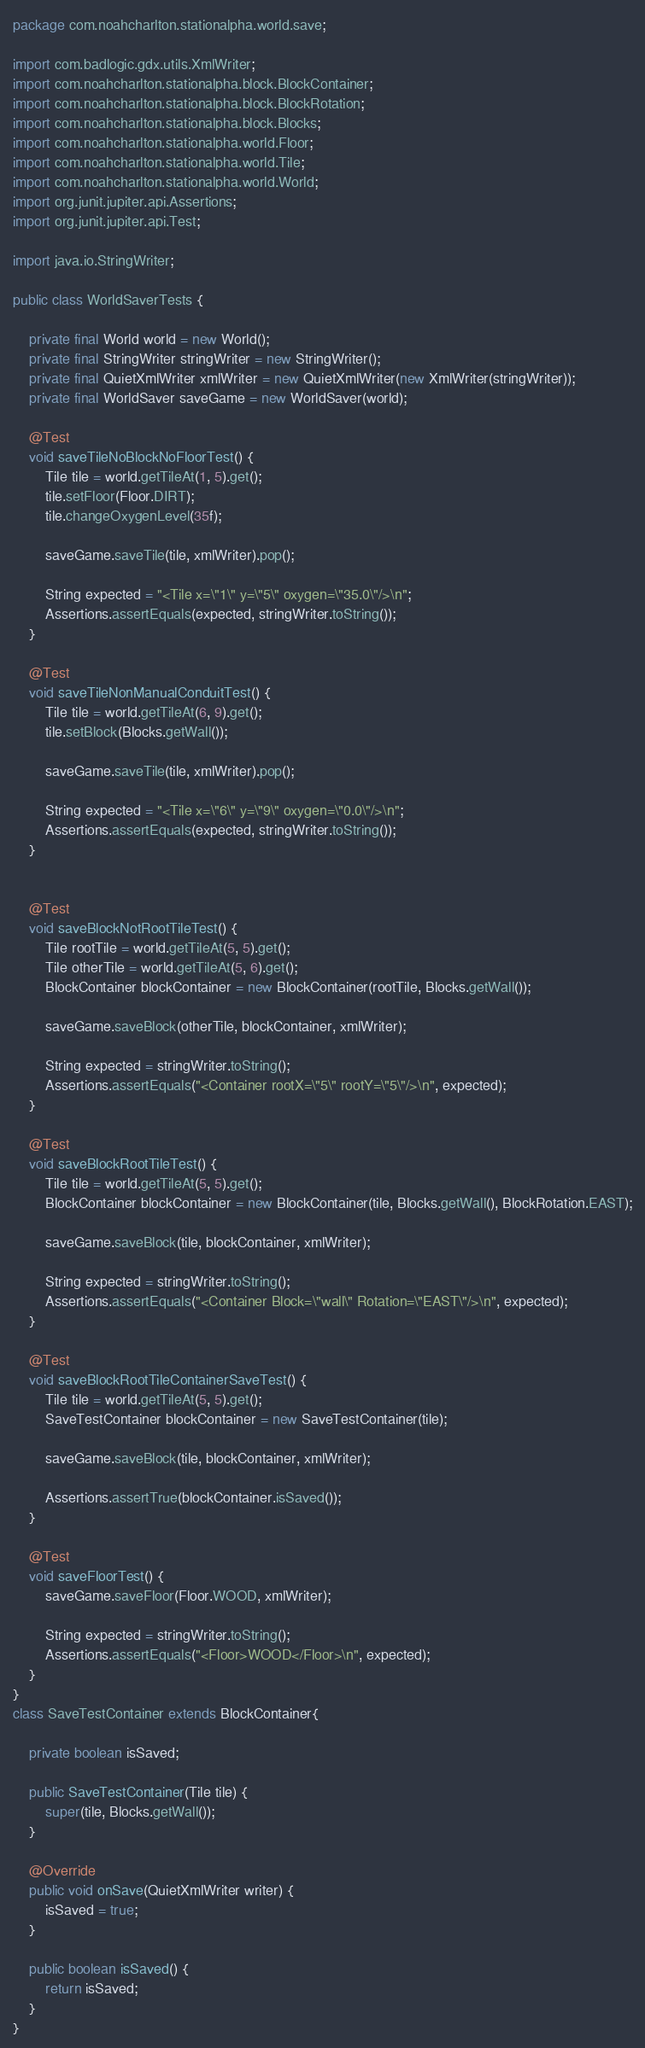Convert code to text. <code><loc_0><loc_0><loc_500><loc_500><_Java_>package com.noahcharlton.stationalpha.world.save;

import com.badlogic.gdx.utils.XmlWriter;
import com.noahcharlton.stationalpha.block.BlockContainer;
import com.noahcharlton.stationalpha.block.BlockRotation;
import com.noahcharlton.stationalpha.block.Blocks;
import com.noahcharlton.stationalpha.world.Floor;
import com.noahcharlton.stationalpha.world.Tile;
import com.noahcharlton.stationalpha.world.World;
import org.junit.jupiter.api.Assertions;
import org.junit.jupiter.api.Test;

import java.io.StringWriter;

public class WorldSaverTests {

    private final World world = new World();
    private final StringWriter stringWriter = new StringWriter();
    private final QuietXmlWriter xmlWriter = new QuietXmlWriter(new XmlWriter(stringWriter));
    private final WorldSaver saveGame = new WorldSaver(world);

    @Test
    void saveTileNoBlockNoFloorTest() {
        Tile tile = world.getTileAt(1, 5).get();
        tile.setFloor(Floor.DIRT);
        tile.changeOxygenLevel(35f);

        saveGame.saveTile(tile, xmlWriter).pop();

        String expected = "<Tile x=\"1\" y=\"5\" oxygen=\"35.0\"/>\n";
        Assertions.assertEquals(expected, stringWriter.toString());
    }

    @Test
    void saveTileNonManualConduitTest() {
        Tile tile = world.getTileAt(6, 9).get();
        tile.setBlock(Blocks.getWall());

        saveGame.saveTile(tile, xmlWriter).pop();

        String expected = "<Tile x=\"6\" y=\"9\" oxygen=\"0.0\"/>\n";
        Assertions.assertEquals(expected, stringWriter.toString());
    }


    @Test
    void saveBlockNotRootTileTest() {
        Tile rootTile = world.getTileAt(5, 5).get();
        Tile otherTile = world.getTileAt(5, 6).get();
        BlockContainer blockContainer = new BlockContainer(rootTile, Blocks.getWall());

        saveGame.saveBlock(otherTile, blockContainer, xmlWriter);

        String expected = stringWriter.toString();
        Assertions.assertEquals("<Container rootX=\"5\" rootY=\"5\"/>\n", expected);
    }

    @Test
    void saveBlockRootTileTest() {
        Tile tile = world.getTileAt(5, 5).get();
        BlockContainer blockContainer = new BlockContainer(tile, Blocks.getWall(), BlockRotation.EAST);

        saveGame.saveBlock(tile, blockContainer, xmlWriter);

        String expected = stringWriter.toString();
        Assertions.assertEquals("<Container Block=\"wall\" Rotation=\"EAST\"/>\n", expected);
    }

    @Test
    void saveBlockRootTileContainerSaveTest() {
        Tile tile = world.getTileAt(5, 5).get();
        SaveTestContainer blockContainer = new SaveTestContainer(tile);

        saveGame.saveBlock(tile, blockContainer, xmlWriter);

        Assertions.assertTrue(blockContainer.isSaved());
    }

    @Test
    void saveFloorTest() {
        saveGame.saveFloor(Floor.WOOD, xmlWriter);

        String expected = stringWriter.toString();
        Assertions.assertEquals("<Floor>WOOD</Floor>\n", expected);
    }
}
class SaveTestContainer extends BlockContainer{

    private boolean isSaved;

    public SaveTestContainer(Tile tile) {
        super(tile, Blocks.getWall());
    }

    @Override
    public void onSave(QuietXmlWriter writer) {
        isSaved = true;
    }

    public boolean isSaved() {
        return isSaved;
    }
}
</code> 